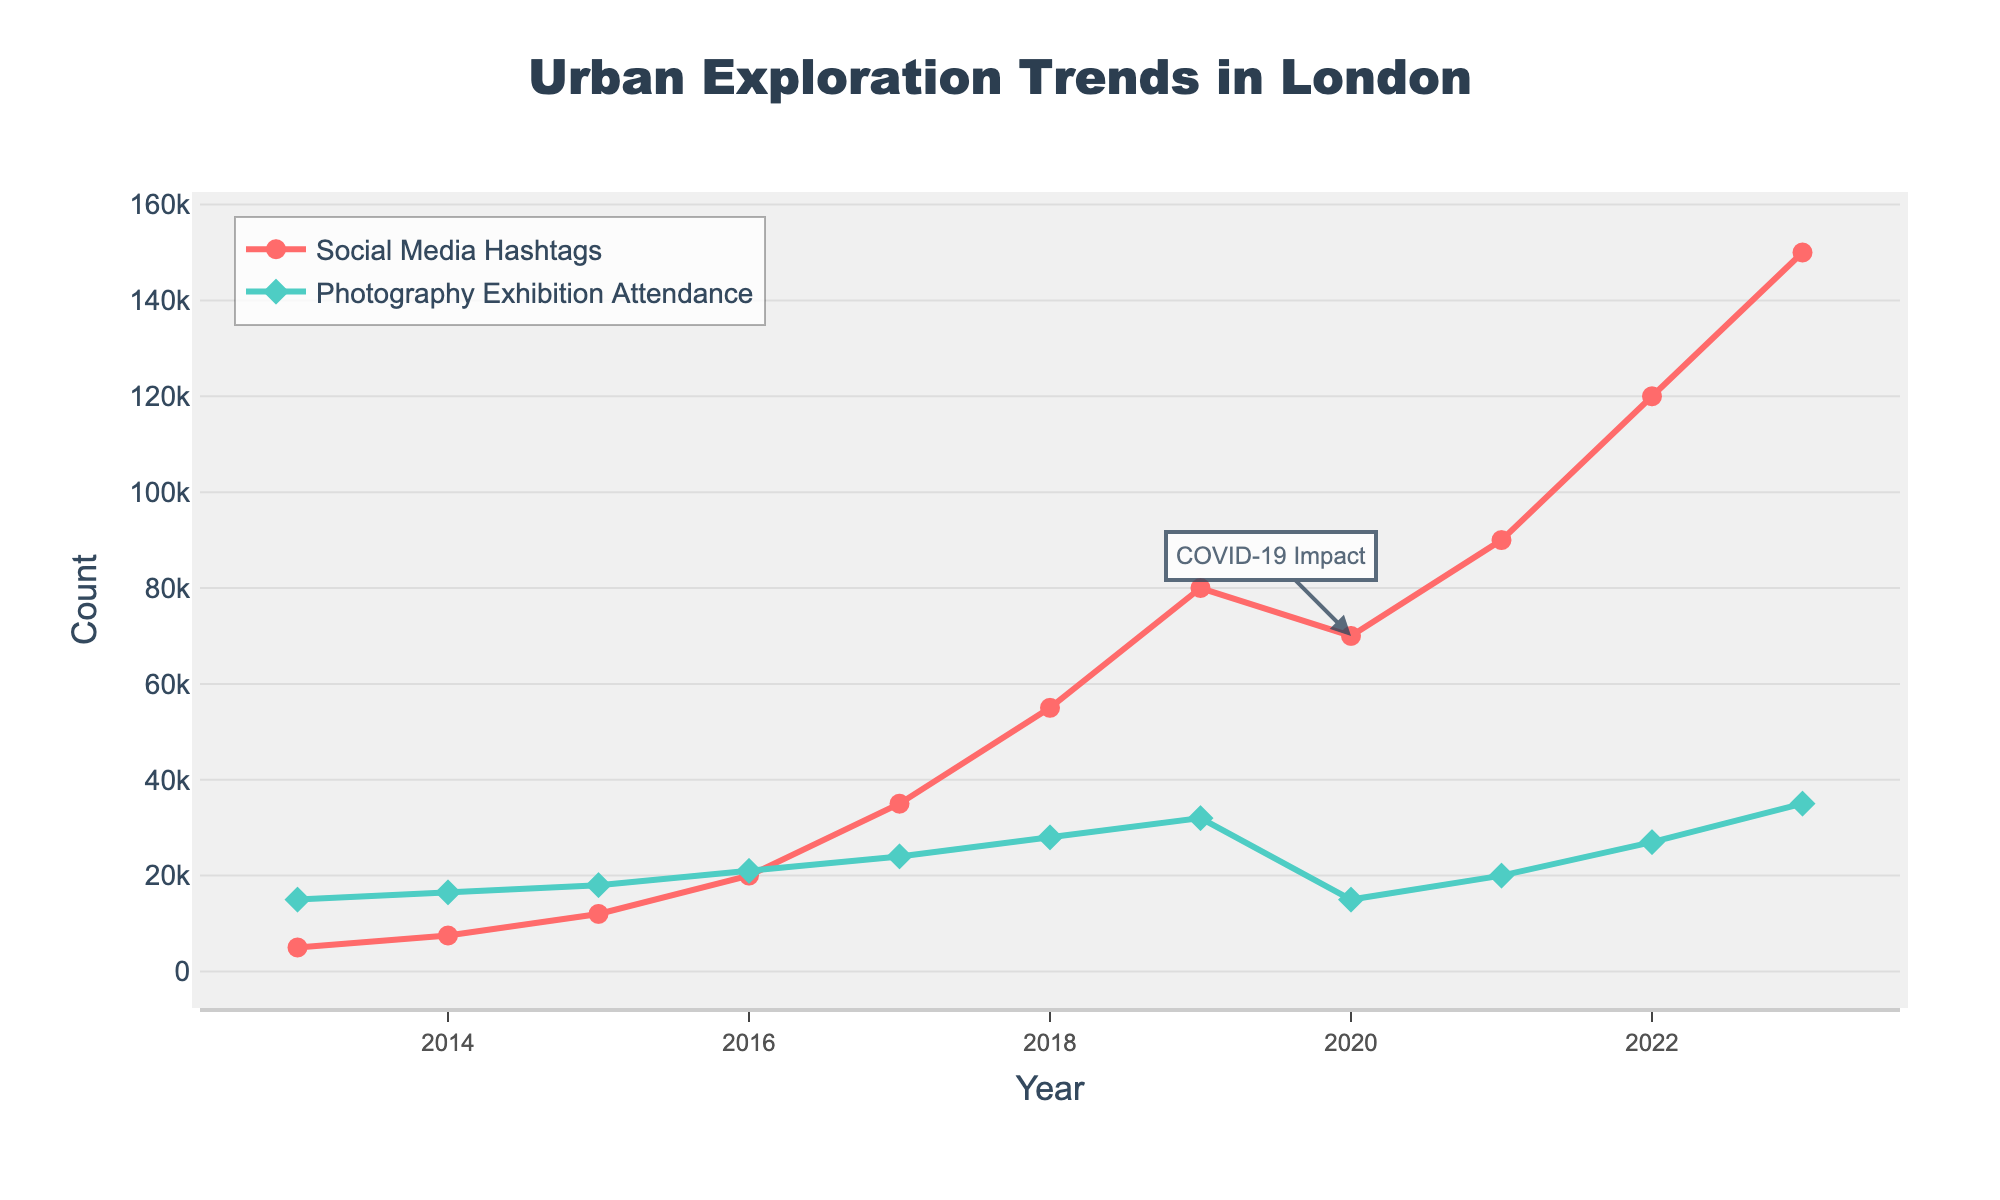How did the popularity of Social Media Hashtags change from 2013 to 2023? In 2013, the count of Social Media Hashtags is 5000. By 2023, it has increased to 150000. Therefore, the popularity increased by 150000 - 5000 = 145000.
Answer: 145000 What significant event likely caused the dip in Photography Exhibition Attendance in 2020? The figure has an annotation pointing to 2020 with the text "COVID-19 Impact", indicating the likely cause of the reduction in attendance.
Answer: COVID-19 Impact Which year saw a higher increase in Social Media Hashtags compared to the previous year, 2017 or 2018? In 2017, the hashtags were 35000, and in 2018, they were 55000, resulting in an increase of 55000 - 35000 = 20000. Comparing this to the previous increase from 2016 to 2017, which was from 20000 to 35000, resulting in an increase of 15000. Thus, 2018 saw a higher increase.
Answer: 2018 Between 2013 and 2023, what is the average growth rate per year in Photography Exhibition Attendance? To find the average growth rate: For 2023, it is 35000, and for 2013, it is 15000. The total growth over 10 years is 35000 - 15000 = 20000. The average growth rate per year is then 20000 / 10 = 2000.
Answer: 2000 In which year did Social Media Hashtags first exceed the 50000 mark? Social Media Hashtags exceed 50000 for the first time in 2018 with a count of 55000.
Answer: 2018 Compare the relative growth of Social Media Hashtags to Photography Exhibition Attendance from 2019 to 2021. In 2019, Social Media Hashtags were 80000, and in 2021, they were 90000, giving a growth of 10000. Photography Exhibition Attendance was 32000 in 2019 and 20000 in 2021, thus showing a decline of 32000 - 20000 = 12000. So, Social Media Hashtags grew while Photography Exhibition Attendance declined.
Answer: Social Media Hashtags grew, Attendance declined How many years are there when Social Media Hashtags were lower than 40000? By looking at the data, Social Media Hashtags were lower than 40000 from 2013 to 2016. Therefore, there are 4 years when hashtags were lower than 40000.
Answer: 4 years What was the trend in Photography Exhibition Attendance between 2016 to 2019? The attendance increased each year during this period, from 21000 in 2016 to 32000 in 2019.
Answer: Increasing What is the ratio of Social Media Hashtags to Photography Exhibition Attendance in 2023? In 2023, Social Media Hashtags are 150000, and Photography Exhibition Attendance is 35000. The ratio is therefore 150000:35000 which simplifies to approximately 4.29:1.
Answer: 4.29:1 